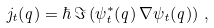Convert formula to latex. <formula><loc_0><loc_0><loc_500><loc_500>j _ { t } ( q ) = \hbar { \, } \Im \left ( \psi _ { t } ^ { * } ( q ) \, \nabla \psi _ { t } ( q ) \right ) \, ,</formula> 